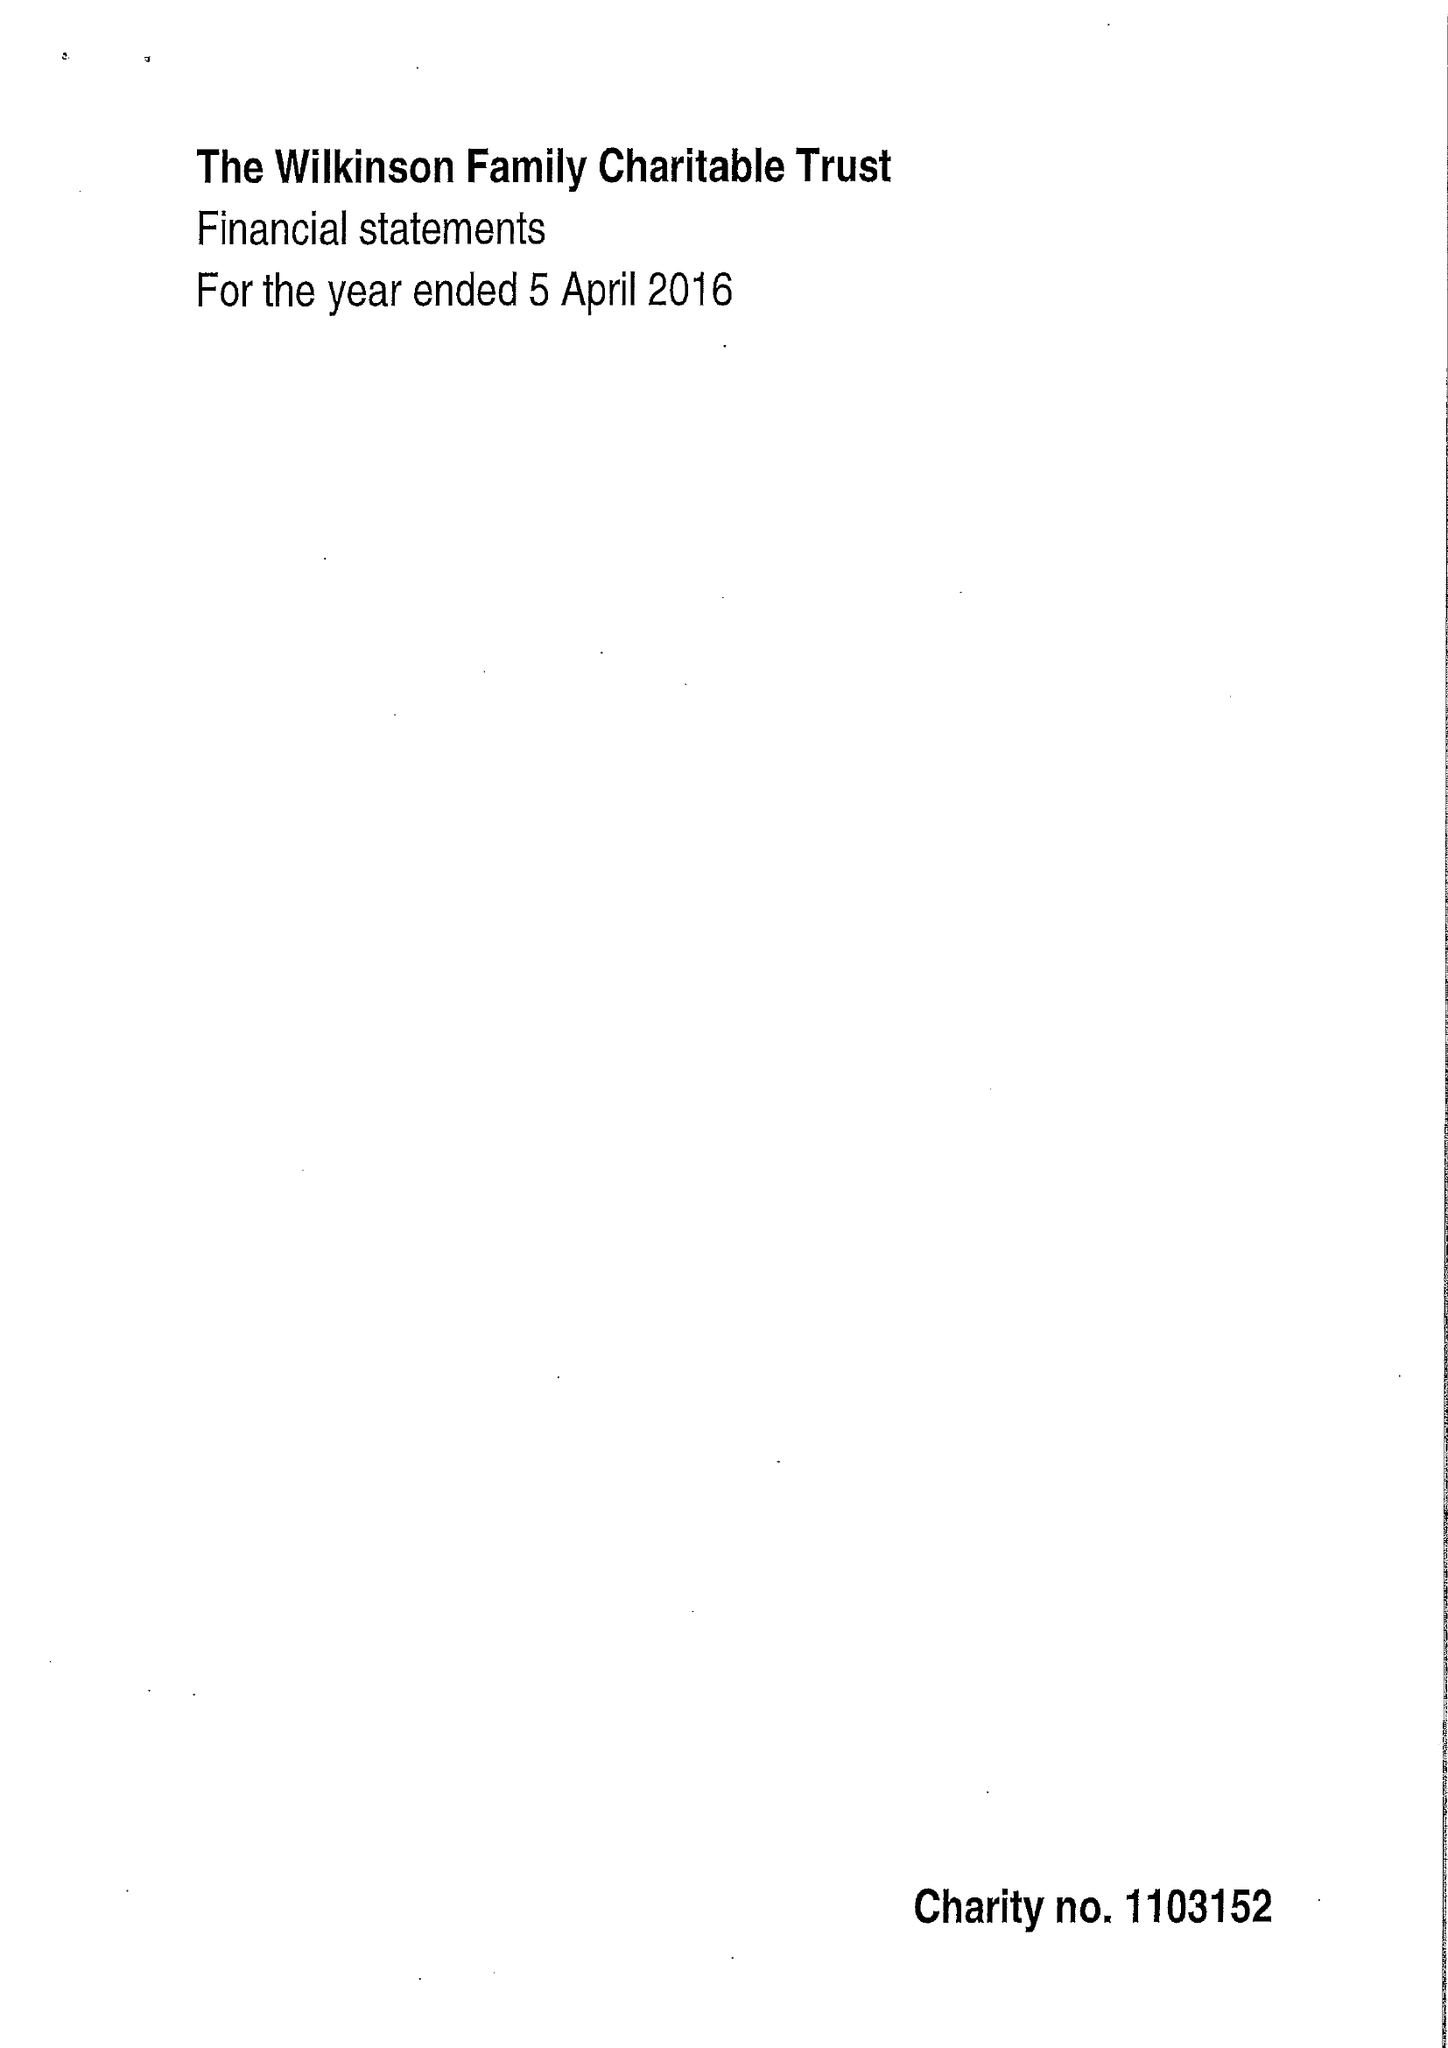What is the value for the address__postcode?
Answer the question using a single word or phrase. NG2 1BJ 